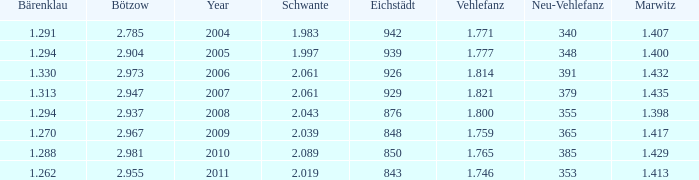What year has a Schwante smaller than 2.043, an Eichstädt smaller than 848, and a Bärenklau smaller than 1.262? 0.0. 